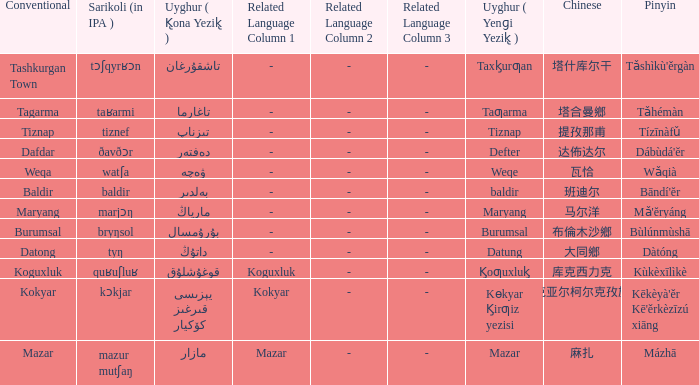Could you parse the entire table as a dict? {'header': ['Conventional', 'Sarikoli (in IPA )', 'Uyghur ( K̢ona Yezik̢ )', 'Related Language Column 1', 'Related Language Column 2', 'Related Language Column 3', 'Uyghur ( Yenɡi Yezik̢ )', 'Chinese', 'Pinyin'], 'rows': [['Tashkurgan Town', 'tɔʃqyrʁɔn', 'تاشقۇرغان', '-', '-', '-', 'Taxk̡urƣan', '塔什库尔干', "Tǎshìkù'ěrgàn"], ['Tagarma', 'taʁarmi', 'تاغارما', '-', '-', '-', 'Taƣarma', '塔合曼鄉', 'Tǎhémàn'], ['Tiznap', 'tiznef', 'تىزناپ', '-', '-', '-', 'Tiznap', '提孜那甫', 'Tízīnàfǔ'], ['Dafdar', 'ðavðɔr', 'دەفتەر', '-', '-', '-', 'Defter', '达佈达尔', "Dábùdá'ĕr"], ['Weqa', 'watʃa', 'ۋەچە', '-', '-', '-', 'Weqe', '瓦恰', 'Wǎqià'], ['Baldir', 'baldir', 'بەلدىر', '-', '-', '-', 'baldir', '班迪尔', "Bāndí'ĕr"], ['Maryang', 'marjɔŋ', 'مارياڭ', '-', '-', '-', 'Maryang', '马尔洋', "Mǎ'ĕryáng"], ['Burumsal', 'bryŋsol', 'بۇرۇمسال', '-', '-', '-', 'Burumsal', '布倫木沙鄉', 'Bùlúnmùshā'], ['Datong', 'tyŋ', 'داتۇڭ', '-', '-', '-', 'Datung', '大同鄉', 'Dàtóng'], ['Koguxluk', 'quʁuʃluʁ', 'قوغۇشلۇق', 'Koguxluk', '-', '-', 'K̡oƣuxluk̡', '库克西力克', 'Kùkèxīlìkè'], ['Kokyar', 'kɔkjar', 'كۆكيار قىرغىز يېزىسى', 'Kokyar', '-', '-', 'Kɵkyar K̡irƣiz yezisi', '科克亚尔柯尔克孜族乡', "Kēkèyà'ěr Kē'ěrkèzīzú xiāng"], ['Mazar', 'mazur mutʃaŋ', 'مازار', 'Mazar', '-', '-', 'Mazar', '麻扎', 'Mázhā']]} Name the pinyin for mazar Mázhā. 